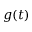<formula> <loc_0><loc_0><loc_500><loc_500>g ( t )</formula> 